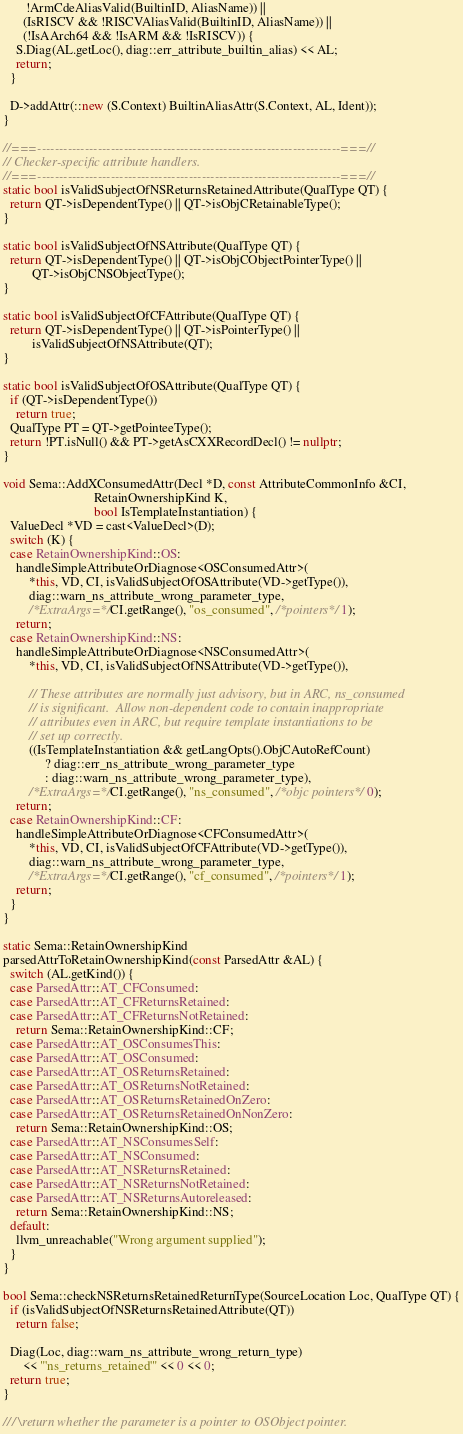<code> <loc_0><loc_0><loc_500><loc_500><_C++_>       !ArmCdeAliasValid(BuiltinID, AliasName)) ||
      (IsRISCV && !RISCVAliasValid(BuiltinID, AliasName)) ||
      (!IsAArch64 && !IsARM && !IsRISCV)) {
    S.Diag(AL.getLoc(), diag::err_attribute_builtin_alias) << AL;
    return;
  }

  D->addAttr(::new (S.Context) BuiltinAliasAttr(S.Context, AL, Ident));
}

//===----------------------------------------------------------------------===//
// Checker-specific attribute handlers.
//===----------------------------------------------------------------------===//
static bool isValidSubjectOfNSReturnsRetainedAttribute(QualType QT) {
  return QT->isDependentType() || QT->isObjCRetainableType();
}

static bool isValidSubjectOfNSAttribute(QualType QT) {
  return QT->isDependentType() || QT->isObjCObjectPointerType() ||
         QT->isObjCNSObjectType();
}

static bool isValidSubjectOfCFAttribute(QualType QT) {
  return QT->isDependentType() || QT->isPointerType() ||
         isValidSubjectOfNSAttribute(QT);
}

static bool isValidSubjectOfOSAttribute(QualType QT) {
  if (QT->isDependentType())
    return true;
  QualType PT = QT->getPointeeType();
  return !PT.isNull() && PT->getAsCXXRecordDecl() != nullptr;
}

void Sema::AddXConsumedAttr(Decl *D, const AttributeCommonInfo &CI,
                            RetainOwnershipKind K,
                            bool IsTemplateInstantiation) {
  ValueDecl *VD = cast<ValueDecl>(D);
  switch (K) {
  case RetainOwnershipKind::OS:
    handleSimpleAttributeOrDiagnose<OSConsumedAttr>(
        *this, VD, CI, isValidSubjectOfOSAttribute(VD->getType()),
        diag::warn_ns_attribute_wrong_parameter_type,
        /*ExtraArgs=*/CI.getRange(), "os_consumed", /*pointers*/ 1);
    return;
  case RetainOwnershipKind::NS:
    handleSimpleAttributeOrDiagnose<NSConsumedAttr>(
        *this, VD, CI, isValidSubjectOfNSAttribute(VD->getType()),

        // These attributes are normally just advisory, but in ARC, ns_consumed
        // is significant.  Allow non-dependent code to contain inappropriate
        // attributes even in ARC, but require template instantiations to be
        // set up correctly.
        ((IsTemplateInstantiation && getLangOpts().ObjCAutoRefCount)
             ? diag::err_ns_attribute_wrong_parameter_type
             : diag::warn_ns_attribute_wrong_parameter_type),
        /*ExtraArgs=*/CI.getRange(), "ns_consumed", /*objc pointers*/ 0);
    return;
  case RetainOwnershipKind::CF:
    handleSimpleAttributeOrDiagnose<CFConsumedAttr>(
        *this, VD, CI, isValidSubjectOfCFAttribute(VD->getType()),
        diag::warn_ns_attribute_wrong_parameter_type,
        /*ExtraArgs=*/CI.getRange(), "cf_consumed", /*pointers*/ 1);
    return;
  }
}

static Sema::RetainOwnershipKind
parsedAttrToRetainOwnershipKind(const ParsedAttr &AL) {
  switch (AL.getKind()) {
  case ParsedAttr::AT_CFConsumed:
  case ParsedAttr::AT_CFReturnsRetained:
  case ParsedAttr::AT_CFReturnsNotRetained:
    return Sema::RetainOwnershipKind::CF;
  case ParsedAttr::AT_OSConsumesThis:
  case ParsedAttr::AT_OSConsumed:
  case ParsedAttr::AT_OSReturnsRetained:
  case ParsedAttr::AT_OSReturnsNotRetained:
  case ParsedAttr::AT_OSReturnsRetainedOnZero:
  case ParsedAttr::AT_OSReturnsRetainedOnNonZero:
    return Sema::RetainOwnershipKind::OS;
  case ParsedAttr::AT_NSConsumesSelf:
  case ParsedAttr::AT_NSConsumed:
  case ParsedAttr::AT_NSReturnsRetained:
  case ParsedAttr::AT_NSReturnsNotRetained:
  case ParsedAttr::AT_NSReturnsAutoreleased:
    return Sema::RetainOwnershipKind::NS;
  default:
    llvm_unreachable("Wrong argument supplied");
  }
}

bool Sema::checkNSReturnsRetainedReturnType(SourceLocation Loc, QualType QT) {
  if (isValidSubjectOfNSReturnsRetainedAttribute(QT))
    return false;

  Diag(Loc, diag::warn_ns_attribute_wrong_return_type)
      << "'ns_returns_retained'" << 0 << 0;
  return true;
}

/// \return whether the parameter is a pointer to OSObject pointer.</code> 